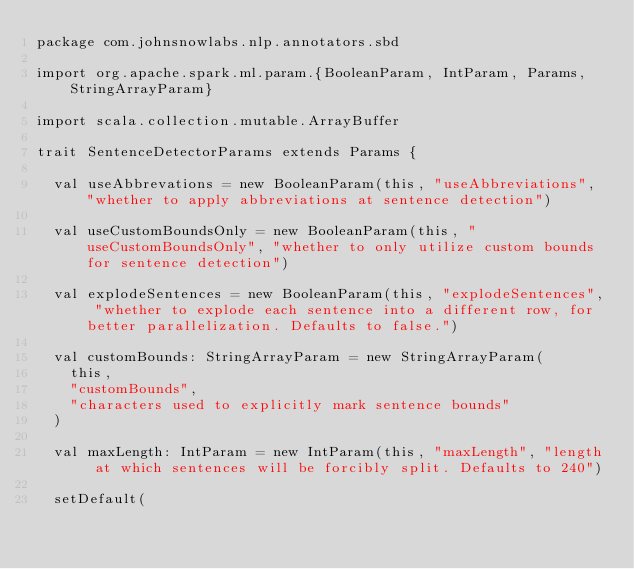Convert code to text. <code><loc_0><loc_0><loc_500><loc_500><_Scala_>package com.johnsnowlabs.nlp.annotators.sbd

import org.apache.spark.ml.param.{BooleanParam, IntParam, Params, StringArrayParam}

import scala.collection.mutable.ArrayBuffer

trait SentenceDetectorParams extends Params {

  val useAbbrevations = new BooleanParam(this, "useAbbreviations", "whether to apply abbreviations at sentence detection")

  val useCustomBoundsOnly = new BooleanParam(this, "useCustomBoundsOnly", "whether to only utilize custom bounds for sentence detection")

  val explodeSentences = new BooleanParam(this, "explodeSentences", "whether to explode each sentence into a different row, for better parallelization. Defaults to false.")

  val customBounds: StringArrayParam = new StringArrayParam(
    this,
    "customBounds",
    "characters used to explicitly mark sentence bounds"
  )

  val maxLength: IntParam = new IntParam(this, "maxLength", "length at which sentences will be forcibly split. Defaults to 240")

  setDefault(</code> 